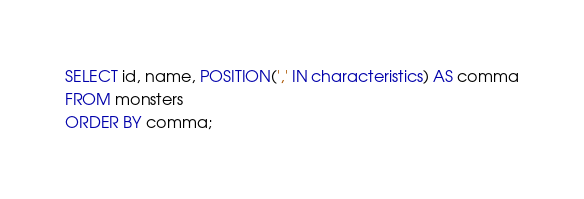<code> <loc_0><loc_0><loc_500><loc_500><_SQL_>SELECT id, name, POSITION(',' IN characteristics) AS comma
FROM monsters
ORDER BY comma;</code> 